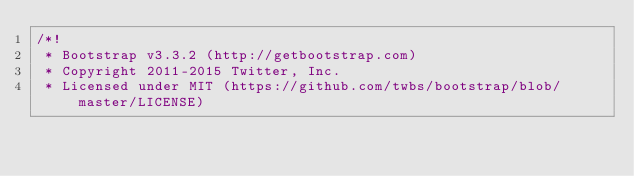Convert code to text. <code><loc_0><loc_0><loc_500><loc_500><_CSS_>/*!
 * Bootstrap v3.3.2 (http://getbootstrap.com)
 * Copyright 2011-2015 Twitter, Inc.
 * Licensed under MIT (https://github.com/twbs/bootstrap/blob/master/LICENSE)</code> 